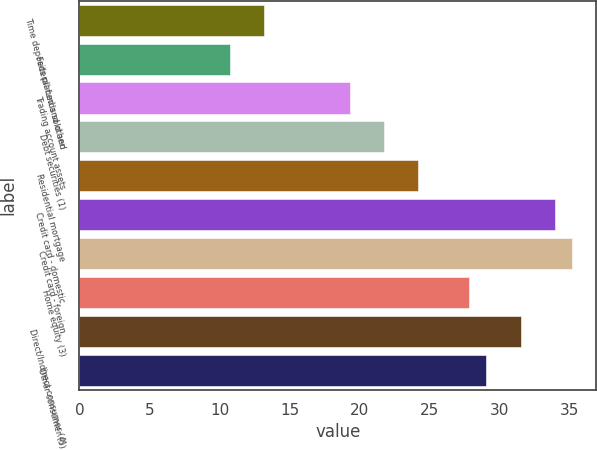<chart> <loc_0><loc_0><loc_500><loc_500><bar_chart><fcel>Time deposits placed and other<fcel>Federal funds sold and<fcel>Trading account assets<fcel>Debt securities (1)<fcel>Residential mortgage<fcel>Credit card - domestic<fcel>Credit card - foreign<fcel>Home equity (3)<fcel>Direct/Indirect consumer (4)<fcel>Other consumer (5)<nl><fcel>13.18<fcel>10.74<fcel>19.28<fcel>21.72<fcel>24.16<fcel>33.92<fcel>35.14<fcel>27.82<fcel>31.48<fcel>29.04<nl></chart> 